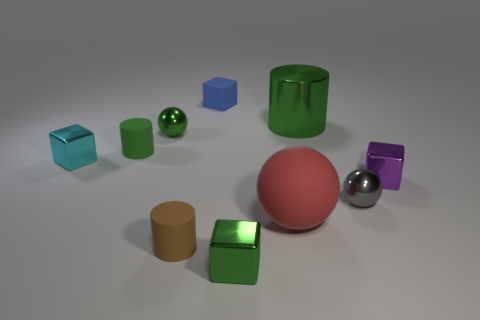What is the material of the green cylinder on the left side of the tiny green shiny object that is in front of the brown cylinder in front of the tiny gray shiny sphere?
Provide a short and direct response. Rubber. Do the ball that is to the left of the brown matte cylinder and the metallic cylinder have the same size?
Provide a short and direct response. No. Are there more matte objects than small metallic blocks?
Make the answer very short. Yes. What number of large objects are brown objects or green cubes?
Give a very brief answer. 0. How many other objects are the same color as the large sphere?
Provide a succinct answer. 0. What number of blue blocks are made of the same material as the tiny purple thing?
Your response must be concise. 0. There is a big object that is in front of the small gray metal ball; is its color the same as the large metal cylinder?
Give a very brief answer. No. How many purple things are large shiny cylinders or shiny things?
Your response must be concise. 1. Are there any other things that have the same material as the large cylinder?
Give a very brief answer. Yes. Are the tiny cube behind the metal cylinder and the big green object made of the same material?
Ensure brevity in your answer.  No. 